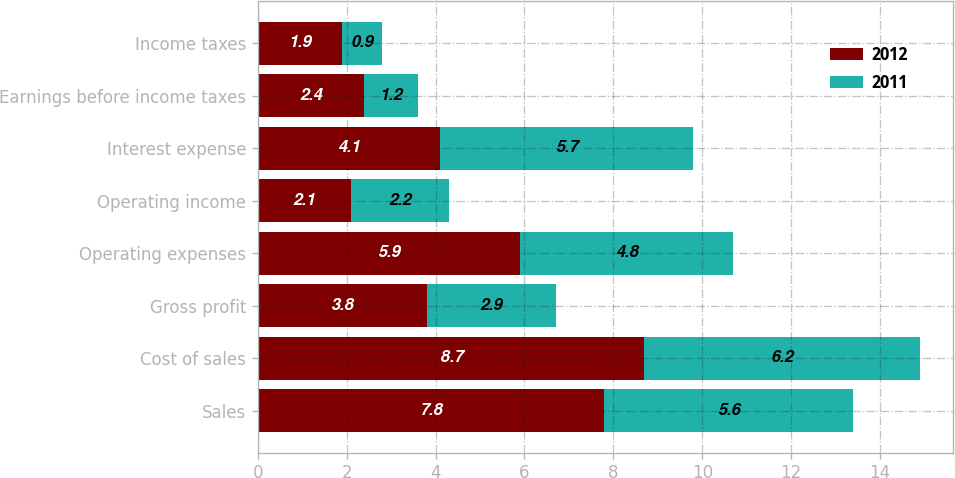Convert chart to OTSL. <chart><loc_0><loc_0><loc_500><loc_500><stacked_bar_chart><ecel><fcel>Sales<fcel>Cost of sales<fcel>Gross profit<fcel>Operating expenses<fcel>Operating income<fcel>Interest expense<fcel>Earnings before income taxes<fcel>Income taxes<nl><fcel>2012<fcel>7.8<fcel>8.7<fcel>3.8<fcel>5.9<fcel>2.1<fcel>4.1<fcel>2.4<fcel>1.9<nl><fcel>2011<fcel>5.6<fcel>6.2<fcel>2.9<fcel>4.8<fcel>2.2<fcel>5.7<fcel>1.2<fcel>0.9<nl></chart> 